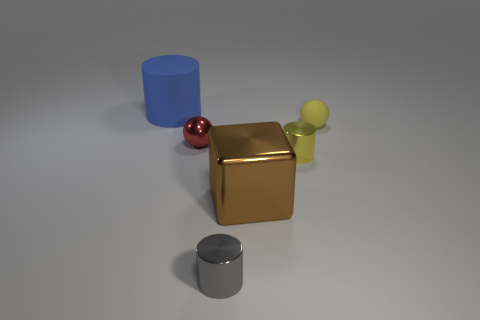Are the thing on the left side of the red metal object and the large thing that is to the right of the small red metallic sphere made of the same material?
Keep it short and to the point. No. There is a object that is on the left side of the tiny gray metal object and in front of the tiny yellow matte object; what is its material?
Keep it short and to the point. Metal. There is a large blue object; is its shape the same as the yellow object in front of the yellow rubber object?
Offer a very short reply. Yes. There is a small yellow thing in front of the matte thing that is right of the big thing that is behind the small rubber sphere; what is it made of?
Ensure brevity in your answer.  Metal. How many other objects are there of the same size as the blue matte cylinder?
Your answer should be very brief. 1. What number of tiny rubber balls are behind the rubber object in front of the big object that is to the left of the brown cube?
Make the answer very short. 0. What material is the thing that is behind the ball that is to the right of the tiny red metal ball made of?
Ensure brevity in your answer.  Rubber. Is there a yellow shiny thing that has the same shape as the big blue rubber thing?
Your answer should be compact. Yes. There is another sphere that is the same size as the red metallic sphere; what is its color?
Ensure brevity in your answer.  Yellow. How many things are big things in front of the yellow matte ball or cylinders left of the tiny gray cylinder?
Offer a very short reply. 2. 